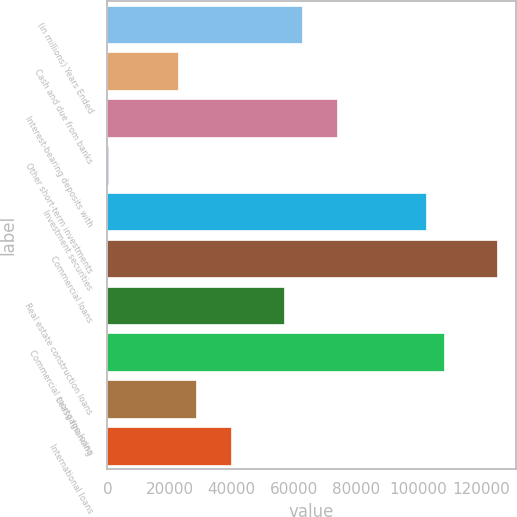Convert chart. <chart><loc_0><loc_0><loc_500><loc_500><bar_chart><fcel>(in millions) Years Ended<fcel>Cash and due from banks<fcel>Interest-bearing deposits with<fcel>Other short-term investments<fcel>Investment securities<fcel>Commercial loans<fcel>Real estate construction loans<fcel>Commercial mortgage loans<fcel>Lease financing<fcel>International loans<nl><fcel>62592.5<fcel>22843<fcel>73949.5<fcel>129<fcel>102342<fcel>125056<fcel>56914<fcel>108020<fcel>28521.5<fcel>39878.5<nl></chart> 